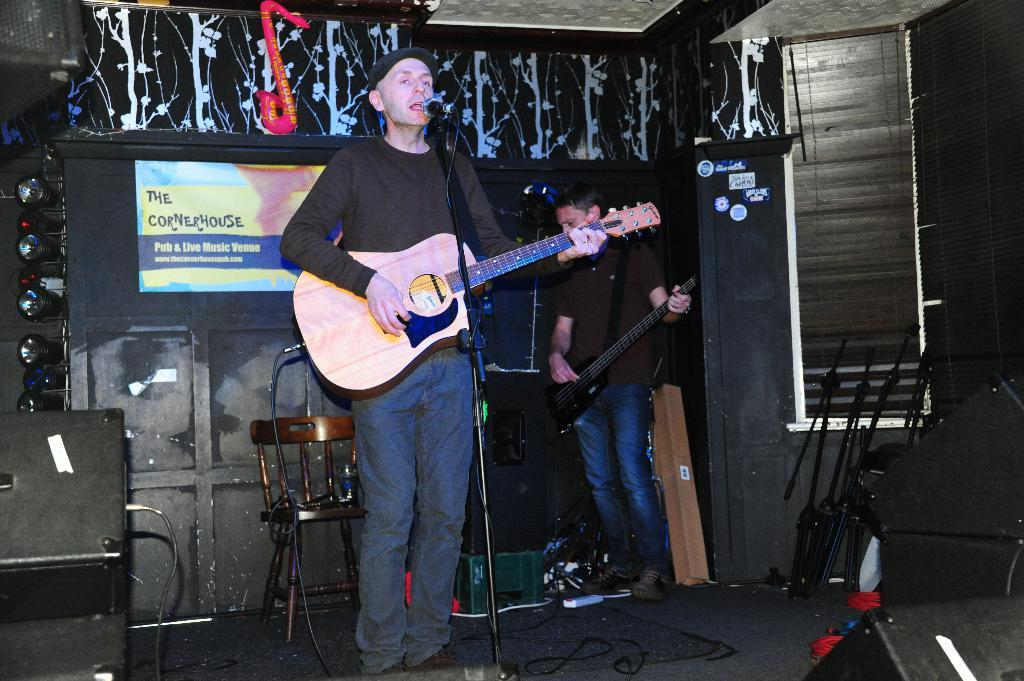Who is present in the image? There are men in the image. What are the men doing in the image? The men are standing in the image. What objects are the men holding in their hands? The men are holding guitars in their hands. What type of yam is being used as a prop in the image? There is no yam present in the image; the men are holding guitars. 